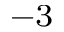<formula> <loc_0><loc_0><loc_500><loc_500>^ { - 3 }</formula> 